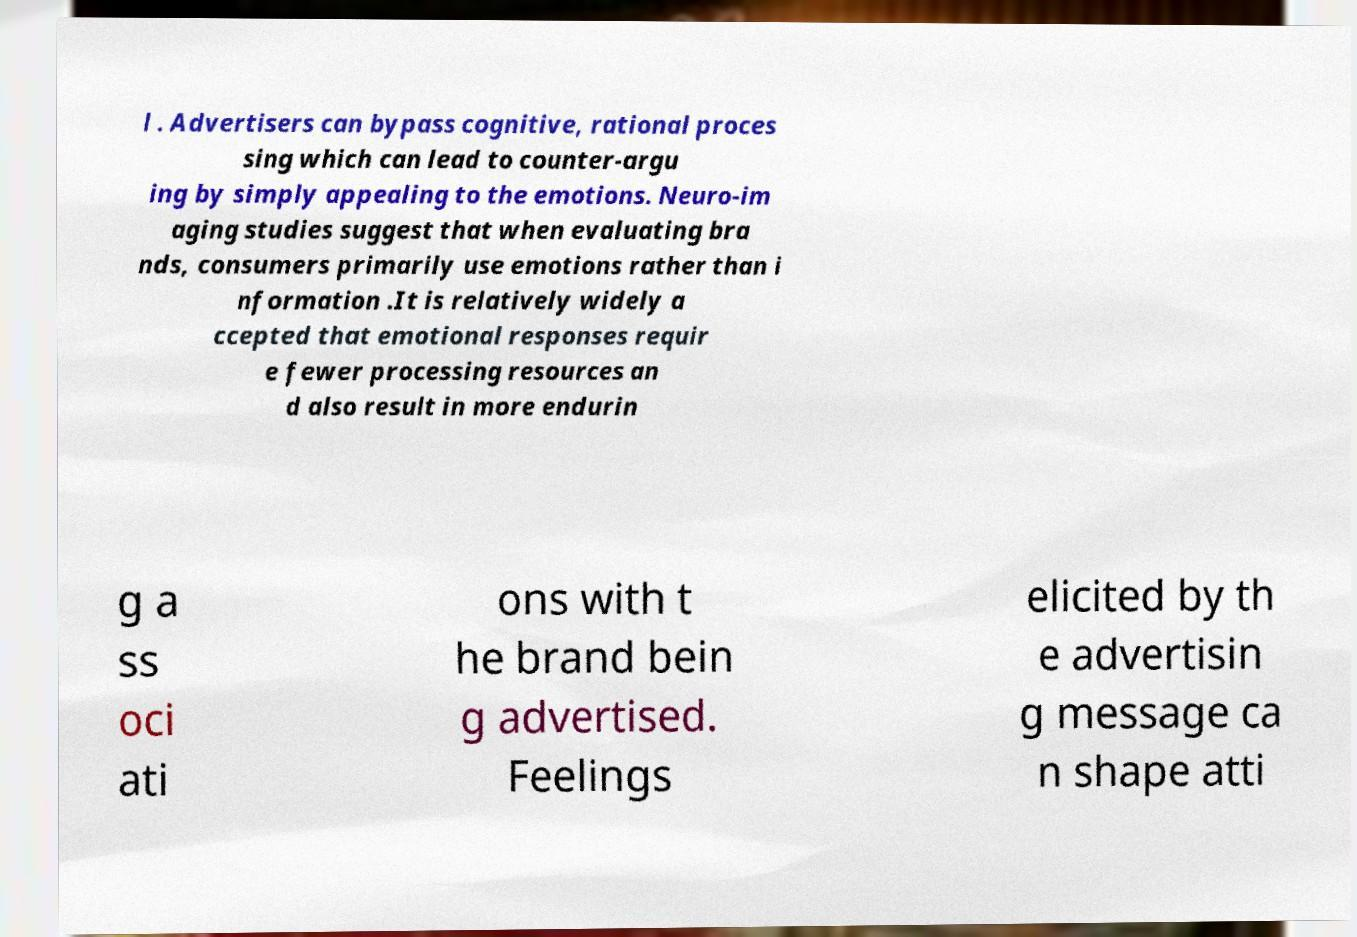Could you assist in decoding the text presented in this image and type it out clearly? l . Advertisers can bypass cognitive, rational proces sing which can lead to counter-argu ing by simply appealing to the emotions. Neuro-im aging studies suggest that when evaluating bra nds, consumers primarily use emotions rather than i nformation .It is relatively widely a ccepted that emotional responses requir e fewer processing resources an d also result in more endurin g a ss oci ati ons with t he brand bein g advertised. Feelings elicited by th e advertisin g message ca n shape atti 